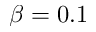Convert formula to latex. <formula><loc_0><loc_0><loc_500><loc_500>\beta = 0 . 1</formula> 